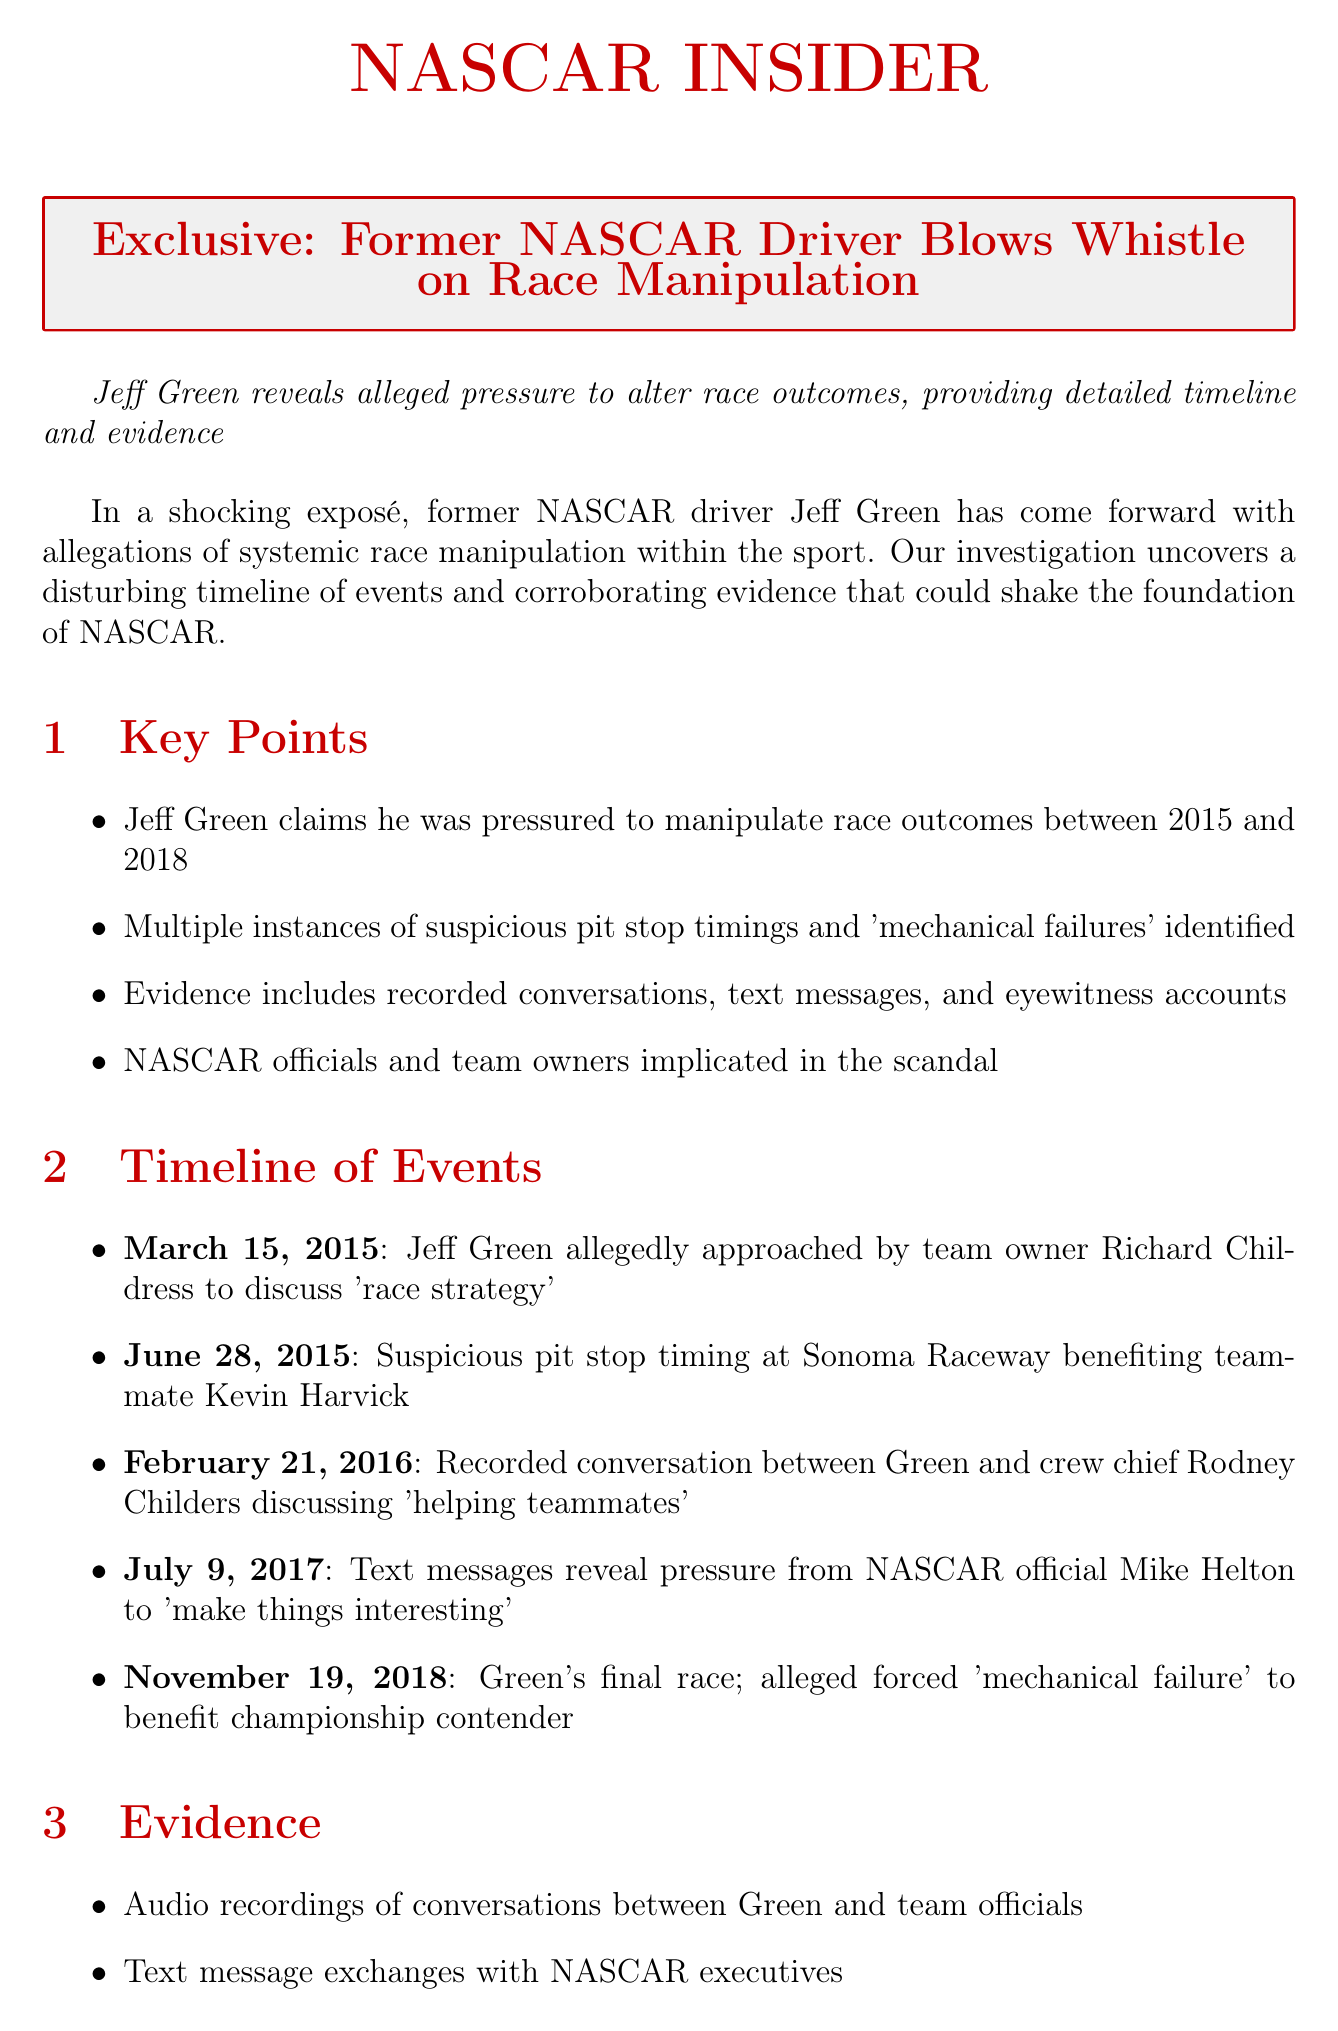What is the name of the former NASCAR driver who made the allegations? The document states that the former NASCAR driver who revealed the allegations is Jeff Green.
Answer: Jeff Green What years does Jeff Green claim he was pressured to manipulate outcomes? The document specifies that Jeff Green claims he was pressured between 2015 and 2018.
Answer: 2015 to 2018 Who allegedly pressured Jeff Green to manipulate race outcomes on July 9, 2017? According to the document, NASCAR official Mike Helton pressured Jeff Green to 'make things interesting'.
Answer: Mike Helton What was the date of Jeff Green's final race? The timeline indicates that Jeff Green's final race took place on November 19, 2018.
Answer: November 19, 2018 Which driver is mentioned as benefiting from suspicious pit stop timings? The document mentions that teammate Kevin Harvick benefited from suspicious pit stop timings.
Answer: Kevin Harvick What type of evidence is mentioned in the document? The evidence includes audio recordings, text message exchanges, telemetry data, sworn statements, and financial records.
Answer: Audio recordings, text message exchanges, telemetry data, sworn statements, financial records What does Dr. Janet Thompson suggest the allegations could rival? Dr. Janet Thompson suggests that the allegations could rival the 2008 Formula 1 'Crashgate' incident.
Answer: 2008 Formula 1 'Crashgate' incident What potential consequence involves legal actions? The document mentions criminal investigations into fraud and sports betting manipulation as a potential consequence.
Answer: Criminal investigations What is NASCAR's stance on the allegations? NASCAR's response states that they categorically deny the allegations and are committed to maintaining integrity.
Answer: NASCAR categorically denies these allegations 